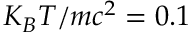<formula> <loc_0><loc_0><loc_500><loc_500>K _ { B } T / m c ^ { 2 } = 0 . 1</formula> 